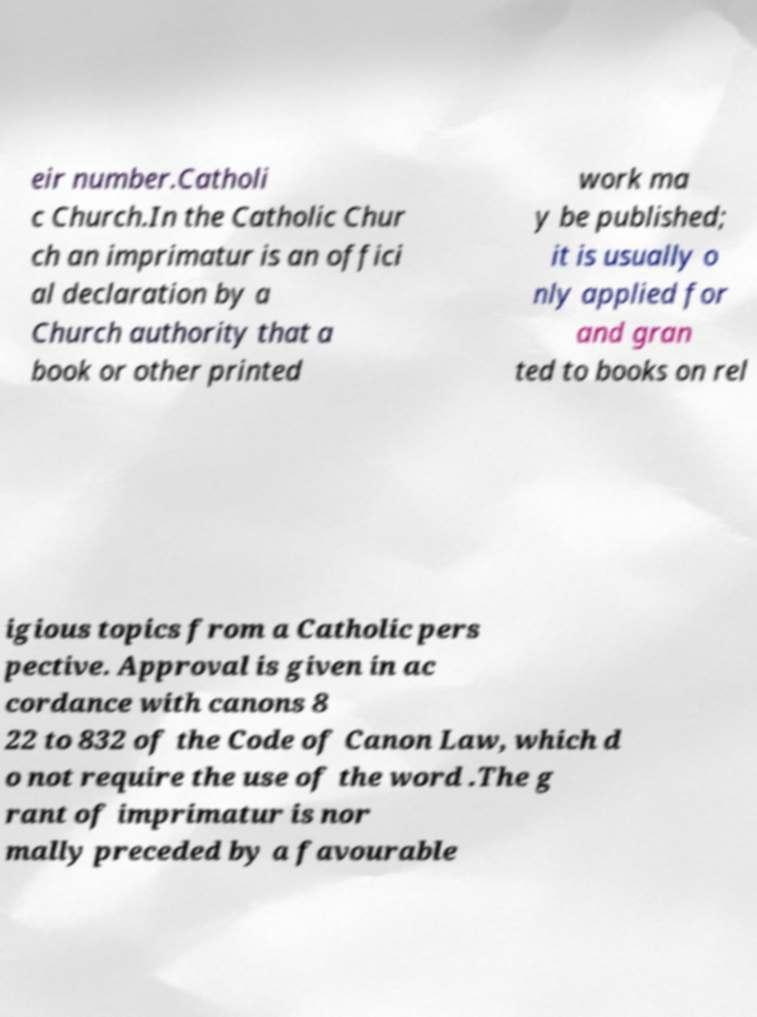What messages or text are displayed in this image? I need them in a readable, typed format. eir number.Catholi c Church.In the Catholic Chur ch an imprimatur is an offici al declaration by a Church authority that a book or other printed work ma y be published; it is usually o nly applied for and gran ted to books on rel igious topics from a Catholic pers pective. Approval is given in ac cordance with canons 8 22 to 832 of the Code of Canon Law, which d o not require the use of the word .The g rant of imprimatur is nor mally preceded by a favourable 